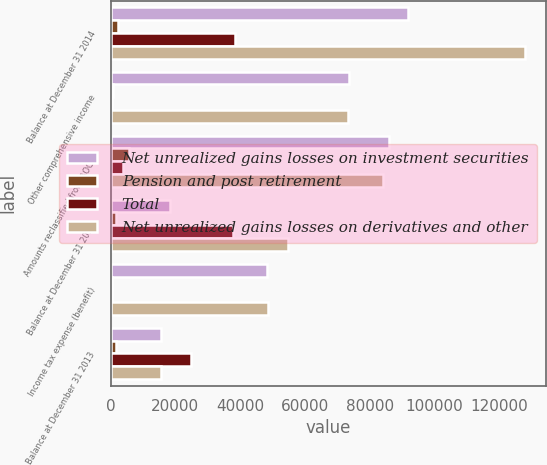Convert chart. <chart><loc_0><loc_0><loc_500><loc_500><stacked_bar_chart><ecel><fcel>Balance at December 31 2014<fcel>Other comprehensive income<fcel>Amounts reclassified from AOCI<fcel>Balance at December 31 2015<fcel>Income tax expense (benefit)<fcel>Balance at December 31 2013<nl><fcel>Net unrealized gains losses on investment securities<fcel>91921<fcel>73552<fcel>86023<fcel>18369<fcel>48422<fcel>15420<nl><fcel>Pension and post retirement<fcel>2226<fcel>680<fcel>5583<fcel>1546<fcel>331<fcel>1556<nl><fcel>Total<fcel>38346<fcel>557<fcel>3718<fcel>37789<fcel>374<fcel>24852<nl><fcel>Net unrealized gains losses on derivatives and other<fcel>128041<fcel>73429<fcel>84158<fcel>54612<fcel>48465<fcel>15420<nl></chart> 